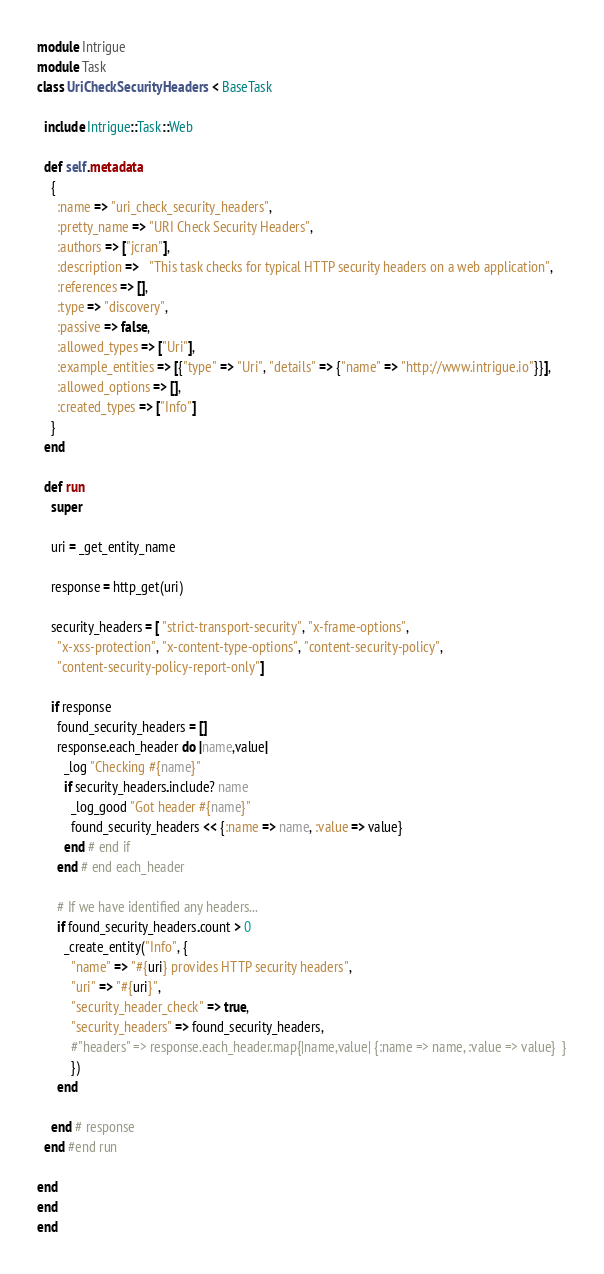<code> <loc_0><loc_0><loc_500><loc_500><_Ruby_>module Intrigue
module Task
class UriCheckSecurityHeaders  < BaseTask

  include Intrigue::Task::Web

  def self.metadata
    {
      :name => "uri_check_security_headers",
      :pretty_name => "URI Check Security Headers",
      :authors => ["jcran"],
      :description =>   "This task checks for typical HTTP security headers on a web application",
      :references => [],
      :type => "discovery",
      :passive => false,
      :allowed_types => ["Uri"],
      :example_entities => [{"type" => "Uri", "details" => {"name" => "http://www.intrigue.io"}}],
      :allowed_options => [],
      :created_types => ["Info"]
    }
  end

  def run
    super

    uri = _get_entity_name

    response = http_get(uri)

    security_headers = [ "strict-transport-security", "x-frame-options",
      "x-xss-protection", "x-content-type-options", "content-security-policy",
      "content-security-policy-report-only"]

    if response
      found_security_headers = []
      response.each_header do |name,value|
        _log "Checking #{name}"
        if security_headers.include? name
          _log_good "Got header #{name}"
          found_security_headers << {:name => name, :value => value}
        end # end if
      end # end each_header

      # If we have identified any headers...
      if found_security_headers.count > 0
        _create_entity("Info", {
          "name" => "#{uri} provides HTTP security headers",
          "uri" => "#{uri}",
          "security_header_check" => true,
          "security_headers" => found_security_headers,
          #"headers" => response.each_header.map{|name,value| {:name => name, :value => value}  }
          })
      end

    end # response
  end #end run

end
end
end
</code> 